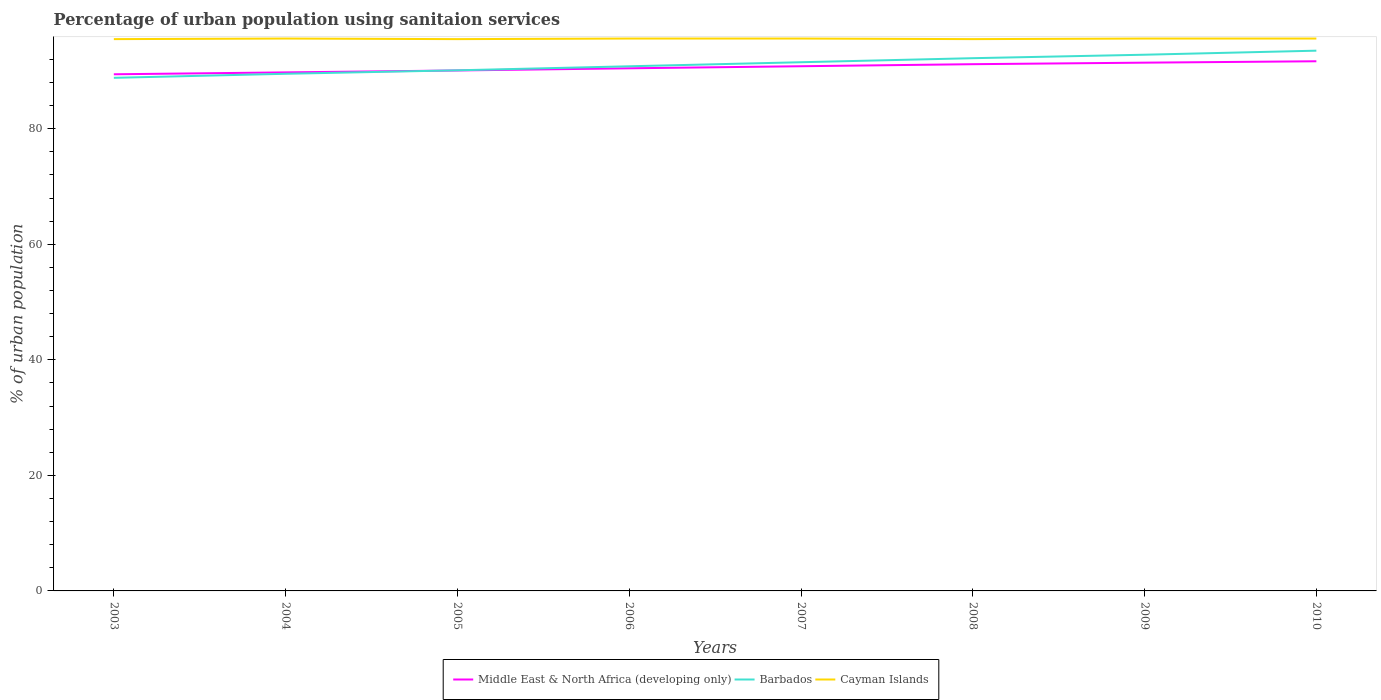Does the line corresponding to Barbados intersect with the line corresponding to Middle East & North Africa (developing only)?
Your answer should be very brief. Yes. Across all years, what is the maximum percentage of urban population using sanitaion services in Cayman Islands?
Offer a terse response. 95.5. In which year was the percentage of urban population using sanitaion services in Cayman Islands maximum?
Keep it short and to the point. 2003. What is the total percentage of urban population using sanitaion services in Middle East & North Africa (developing only) in the graph?
Your response must be concise. -0.33. What is the difference between the highest and the second highest percentage of urban population using sanitaion services in Cayman Islands?
Ensure brevity in your answer.  0.1. What is the difference between the highest and the lowest percentage of urban population using sanitaion services in Middle East & North Africa (developing only)?
Provide a short and direct response. 4. How many years are there in the graph?
Provide a succinct answer. 8. What is the difference between two consecutive major ticks on the Y-axis?
Make the answer very short. 20. Are the values on the major ticks of Y-axis written in scientific E-notation?
Keep it short and to the point. No. How many legend labels are there?
Offer a terse response. 3. How are the legend labels stacked?
Offer a terse response. Horizontal. What is the title of the graph?
Give a very brief answer. Percentage of urban population using sanitaion services. Does "Czech Republic" appear as one of the legend labels in the graph?
Ensure brevity in your answer.  No. What is the label or title of the X-axis?
Your response must be concise. Years. What is the label or title of the Y-axis?
Provide a succinct answer. % of urban population. What is the % of urban population in Middle East & North Africa (developing only) in 2003?
Provide a short and direct response. 89.41. What is the % of urban population in Barbados in 2003?
Your response must be concise. 88.8. What is the % of urban population in Cayman Islands in 2003?
Keep it short and to the point. 95.5. What is the % of urban population in Middle East & North Africa (developing only) in 2004?
Your answer should be very brief. 89.74. What is the % of urban population in Barbados in 2004?
Give a very brief answer. 89.5. What is the % of urban population of Cayman Islands in 2004?
Offer a very short reply. 95.6. What is the % of urban population of Middle East & North Africa (developing only) in 2005?
Your answer should be compact. 90.07. What is the % of urban population in Barbados in 2005?
Provide a short and direct response. 90.1. What is the % of urban population of Cayman Islands in 2005?
Ensure brevity in your answer.  95.5. What is the % of urban population in Middle East & North Africa (developing only) in 2006?
Give a very brief answer. 90.45. What is the % of urban population of Barbados in 2006?
Keep it short and to the point. 90.8. What is the % of urban population of Cayman Islands in 2006?
Provide a short and direct response. 95.6. What is the % of urban population in Middle East & North Africa (developing only) in 2007?
Your response must be concise. 90.81. What is the % of urban population of Barbados in 2007?
Give a very brief answer. 91.5. What is the % of urban population of Cayman Islands in 2007?
Your answer should be compact. 95.6. What is the % of urban population of Middle East & North Africa (developing only) in 2008?
Make the answer very short. 91.16. What is the % of urban population of Barbados in 2008?
Your answer should be very brief. 92.2. What is the % of urban population in Cayman Islands in 2008?
Your answer should be very brief. 95.5. What is the % of urban population in Middle East & North Africa (developing only) in 2009?
Your answer should be very brief. 91.43. What is the % of urban population of Barbados in 2009?
Keep it short and to the point. 92.8. What is the % of urban population of Cayman Islands in 2009?
Your answer should be very brief. 95.6. What is the % of urban population of Middle East & North Africa (developing only) in 2010?
Offer a very short reply. 91.67. What is the % of urban population of Barbados in 2010?
Ensure brevity in your answer.  93.5. What is the % of urban population of Cayman Islands in 2010?
Give a very brief answer. 95.6. Across all years, what is the maximum % of urban population in Middle East & North Africa (developing only)?
Your response must be concise. 91.67. Across all years, what is the maximum % of urban population in Barbados?
Provide a succinct answer. 93.5. Across all years, what is the maximum % of urban population in Cayman Islands?
Ensure brevity in your answer.  95.6. Across all years, what is the minimum % of urban population of Middle East & North Africa (developing only)?
Keep it short and to the point. 89.41. Across all years, what is the minimum % of urban population of Barbados?
Offer a very short reply. 88.8. Across all years, what is the minimum % of urban population in Cayman Islands?
Ensure brevity in your answer.  95.5. What is the total % of urban population in Middle East & North Africa (developing only) in the graph?
Keep it short and to the point. 724.74. What is the total % of urban population of Barbados in the graph?
Ensure brevity in your answer.  729.2. What is the total % of urban population in Cayman Islands in the graph?
Your answer should be compact. 764.5. What is the difference between the % of urban population of Middle East & North Africa (developing only) in 2003 and that in 2004?
Ensure brevity in your answer.  -0.33. What is the difference between the % of urban population of Barbados in 2003 and that in 2004?
Make the answer very short. -0.7. What is the difference between the % of urban population in Cayman Islands in 2003 and that in 2004?
Your answer should be compact. -0.1. What is the difference between the % of urban population in Middle East & North Africa (developing only) in 2003 and that in 2005?
Provide a succinct answer. -0.66. What is the difference between the % of urban population of Cayman Islands in 2003 and that in 2005?
Ensure brevity in your answer.  0. What is the difference between the % of urban population of Middle East & North Africa (developing only) in 2003 and that in 2006?
Provide a succinct answer. -1.04. What is the difference between the % of urban population in Barbados in 2003 and that in 2006?
Offer a terse response. -2. What is the difference between the % of urban population in Middle East & North Africa (developing only) in 2003 and that in 2007?
Offer a terse response. -1.39. What is the difference between the % of urban population in Cayman Islands in 2003 and that in 2007?
Make the answer very short. -0.1. What is the difference between the % of urban population in Middle East & North Africa (developing only) in 2003 and that in 2008?
Provide a short and direct response. -1.75. What is the difference between the % of urban population of Cayman Islands in 2003 and that in 2008?
Your response must be concise. 0. What is the difference between the % of urban population in Middle East & North Africa (developing only) in 2003 and that in 2009?
Offer a terse response. -2.01. What is the difference between the % of urban population of Cayman Islands in 2003 and that in 2009?
Offer a very short reply. -0.1. What is the difference between the % of urban population in Middle East & North Africa (developing only) in 2003 and that in 2010?
Give a very brief answer. -2.25. What is the difference between the % of urban population in Middle East & North Africa (developing only) in 2004 and that in 2005?
Your response must be concise. -0.33. What is the difference between the % of urban population in Barbados in 2004 and that in 2005?
Ensure brevity in your answer.  -0.6. What is the difference between the % of urban population in Cayman Islands in 2004 and that in 2005?
Offer a very short reply. 0.1. What is the difference between the % of urban population in Middle East & North Africa (developing only) in 2004 and that in 2006?
Keep it short and to the point. -0.71. What is the difference between the % of urban population in Barbados in 2004 and that in 2006?
Give a very brief answer. -1.3. What is the difference between the % of urban population in Middle East & North Africa (developing only) in 2004 and that in 2007?
Provide a short and direct response. -1.06. What is the difference between the % of urban population in Barbados in 2004 and that in 2007?
Your answer should be compact. -2. What is the difference between the % of urban population of Cayman Islands in 2004 and that in 2007?
Make the answer very short. 0. What is the difference between the % of urban population of Middle East & North Africa (developing only) in 2004 and that in 2008?
Your response must be concise. -1.42. What is the difference between the % of urban population of Cayman Islands in 2004 and that in 2008?
Ensure brevity in your answer.  0.1. What is the difference between the % of urban population of Middle East & North Africa (developing only) in 2004 and that in 2009?
Give a very brief answer. -1.69. What is the difference between the % of urban population of Barbados in 2004 and that in 2009?
Offer a terse response. -3.3. What is the difference between the % of urban population in Middle East & North Africa (developing only) in 2004 and that in 2010?
Provide a succinct answer. -1.92. What is the difference between the % of urban population in Middle East & North Africa (developing only) in 2005 and that in 2006?
Offer a terse response. -0.38. What is the difference between the % of urban population of Barbados in 2005 and that in 2006?
Your answer should be compact. -0.7. What is the difference between the % of urban population of Middle East & North Africa (developing only) in 2005 and that in 2007?
Provide a succinct answer. -0.73. What is the difference between the % of urban population of Barbados in 2005 and that in 2007?
Offer a very short reply. -1.4. What is the difference between the % of urban population of Cayman Islands in 2005 and that in 2007?
Keep it short and to the point. -0.1. What is the difference between the % of urban population in Middle East & North Africa (developing only) in 2005 and that in 2008?
Offer a very short reply. -1.09. What is the difference between the % of urban population of Barbados in 2005 and that in 2008?
Provide a short and direct response. -2.1. What is the difference between the % of urban population in Middle East & North Africa (developing only) in 2005 and that in 2009?
Your response must be concise. -1.35. What is the difference between the % of urban population in Barbados in 2005 and that in 2009?
Ensure brevity in your answer.  -2.7. What is the difference between the % of urban population of Middle East & North Africa (developing only) in 2005 and that in 2010?
Give a very brief answer. -1.59. What is the difference between the % of urban population in Middle East & North Africa (developing only) in 2006 and that in 2007?
Offer a terse response. -0.36. What is the difference between the % of urban population in Barbados in 2006 and that in 2007?
Your answer should be compact. -0.7. What is the difference between the % of urban population in Middle East & North Africa (developing only) in 2006 and that in 2008?
Give a very brief answer. -0.71. What is the difference between the % of urban population of Cayman Islands in 2006 and that in 2008?
Your response must be concise. 0.1. What is the difference between the % of urban population in Middle East & North Africa (developing only) in 2006 and that in 2009?
Make the answer very short. -0.98. What is the difference between the % of urban population of Cayman Islands in 2006 and that in 2009?
Your answer should be very brief. 0. What is the difference between the % of urban population in Middle East & North Africa (developing only) in 2006 and that in 2010?
Make the answer very short. -1.22. What is the difference between the % of urban population of Middle East & North Africa (developing only) in 2007 and that in 2008?
Your response must be concise. -0.36. What is the difference between the % of urban population in Cayman Islands in 2007 and that in 2008?
Provide a short and direct response. 0.1. What is the difference between the % of urban population of Middle East & North Africa (developing only) in 2007 and that in 2009?
Provide a short and direct response. -0.62. What is the difference between the % of urban population in Barbados in 2007 and that in 2009?
Your response must be concise. -1.3. What is the difference between the % of urban population of Cayman Islands in 2007 and that in 2009?
Ensure brevity in your answer.  0. What is the difference between the % of urban population in Middle East & North Africa (developing only) in 2007 and that in 2010?
Keep it short and to the point. -0.86. What is the difference between the % of urban population in Barbados in 2007 and that in 2010?
Offer a very short reply. -2. What is the difference between the % of urban population in Cayman Islands in 2007 and that in 2010?
Ensure brevity in your answer.  0. What is the difference between the % of urban population of Middle East & North Africa (developing only) in 2008 and that in 2009?
Your answer should be compact. -0.27. What is the difference between the % of urban population in Cayman Islands in 2008 and that in 2009?
Provide a short and direct response. -0.1. What is the difference between the % of urban population in Middle East & North Africa (developing only) in 2008 and that in 2010?
Your answer should be very brief. -0.5. What is the difference between the % of urban population in Cayman Islands in 2008 and that in 2010?
Provide a succinct answer. -0.1. What is the difference between the % of urban population in Middle East & North Africa (developing only) in 2009 and that in 2010?
Offer a very short reply. -0.24. What is the difference between the % of urban population of Barbados in 2009 and that in 2010?
Your response must be concise. -0.7. What is the difference between the % of urban population of Cayman Islands in 2009 and that in 2010?
Offer a very short reply. 0. What is the difference between the % of urban population of Middle East & North Africa (developing only) in 2003 and the % of urban population of Barbados in 2004?
Provide a short and direct response. -0.09. What is the difference between the % of urban population of Middle East & North Africa (developing only) in 2003 and the % of urban population of Cayman Islands in 2004?
Make the answer very short. -6.19. What is the difference between the % of urban population of Barbados in 2003 and the % of urban population of Cayman Islands in 2004?
Your response must be concise. -6.8. What is the difference between the % of urban population in Middle East & North Africa (developing only) in 2003 and the % of urban population in Barbados in 2005?
Make the answer very short. -0.69. What is the difference between the % of urban population of Middle East & North Africa (developing only) in 2003 and the % of urban population of Cayman Islands in 2005?
Offer a very short reply. -6.09. What is the difference between the % of urban population in Middle East & North Africa (developing only) in 2003 and the % of urban population in Barbados in 2006?
Provide a short and direct response. -1.39. What is the difference between the % of urban population of Middle East & North Africa (developing only) in 2003 and the % of urban population of Cayman Islands in 2006?
Offer a terse response. -6.19. What is the difference between the % of urban population in Middle East & North Africa (developing only) in 2003 and the % of urban population in Barbados in 2007?
Give a very brief answer. -2.09. What is the difference between the % of urban population of Middle East & North Africa (developing only) in 2003 and the % of urban population of Cayman Islands in 2007?
Give a very brief answer. -6.19. What is the difference between the % of urban population in Barbados in 2003 and the % of urban population in Cayman Islands in 2007?
Keep it short and to the point. -6.8. What is the difference between the % of urban population of Middle East & North Africa (developing only) in 2003 and the % of urban population of Barbados in 2008?
Ensure brevity in your answer.  -2.79. What is the difference between the % of urban population in Middle East & North Africa (developing only) in 2003 and the % of urban population in Cayman Islands in 2008?
Offer a very short reply. -6.09. What is the difference between the % of urban population in Middle East & North Africa (developing only) in 2003 and the % of urban population in Barbados in 2009?
Your answer should be compact. -3.39. What is the difference between the % of urban population of Middle East & North Africa (developing only) in 2003 and the % of urban population of Cayman Islands in 2009?
Your answer should be very brief. -6.19. What is the difference between the % of urban population of Middle East & North Africa (developing only) in 2003 and the % of urban population of Barbados in 2010?
Offer a very short reply. -4.09. What is the difference between the % of urban population in Middle East & North Africa (developing only) in 2003 and the % of urban population in Cayman Islands in 2010?
Offer a very short reply. -6.19. What is the difference between the % of urban population of Middle East & North Africa (developing only) in 2004 and the % of urban population of Barbados in 2005?
Provide a short and direct response. -0.36. What is the difference between the % of urban population in Middle East & North Africa (developing only) in 2004 and the % of urban population in Cayman Islands in 2005?
Keep it short and to the point. -5.76. What is the difference between the % of urban population of Barbados in 2004 and the % of urban population of Cayman Islands in 2005?
Keep it short and to the point. -6. What is the difference between the % of urban population in Middle East & North Africa (developing only) in 2004 and the % of urban population in Barbados in 2006?
Offer a very short reply. -1.06. What is the difference between the % of urban population in Middle East & North Africa (developing only) in 2004 and the % of urban population in Cayman Islands in 2006?
Offer a very short reply. -5.86. What is the difference between the % of urban population in Barbados in 2004 and the % of urban population in Cayman Islands in 2006?
Your response must be concise. -6.1. What is the difference between the % of urban population in Middle East & North Africa (developing only) in 2004 and the % of urban population in Barbados in 2007?
Provide a short and direct response. -1.76. What is the difference between the % of urban population of Middle East & North Africa (developing only) in 2004 and the % of urban population of Cayman Islands in 2007?
Your answer should be compact. -5.86. What is the difference between the % of urban population of Middle East & North Africa (developing only) in 2004 and the % of urban population of Barbados in 2008?
Make the answer very short. -2.46. What is the difference between the % of urban population in Middle East & North Africa (developing only) in 2004 and the % of urban population in Cayman Islands in 2008?
Keep it short and to the point. -5.76. What is the difference between the % of urban population in Barbados in 2004 and the % of urban population in Cayman Islands in 2008?
Your answer should be very brief. -6. What is the difference between the % of urban population in Middle East & North Africa (developing only) in 2004 and the % of urban population in Barbados in 2009?
Your response must be concise. -3.06. What is the difference between the % of urban population of Middle East & North Africa (developing only) in 2004 and the % of urban population of Cayman Islands in 2009?
Provide a succinct answer. -5.86. What is the difference between the % of urban population in Middle East & North Africa (developing only) in 2004 and the % of urban population in Barbados in 2010?
Offer a very short reply. -3.76. What is the difference between the % of urban population of Middle East & North Africa (developing only) in 2004 and the % of urban population of Cayman Islands in 2010?
Offer a terse response. -5.86. What is the difference between the % of urban population in Barbados in 2004 and the % of urban population in Cayman Islands in 2010?
Your answer should be compact. -6.1. What is the difference between the % of urban population in Middle East & North Africa (developing only) in 2005 and the % of urban population in Barbados in 2006?
Keep it short and to the point. -0.73. What is the difference between the % of urban population in Middle East & North Africa (developing only) in 2005 and the % of urban population in Cayman Islands in 2006?
Make the answer very short. -5.53. What is the difference between the % of urban population of Middle East & North Africa (developing only) in 2005 and the % of urban population of Barbados in 2007?
Offer a very short reply. -1.43. What is the difference between the % of urban population in Middle East & North Africa (developing only) in 2005 and the % of urban population in Cayman Islands in 2007?
Provide a short and direct response. -5.53. What is the difference between the % of urban population of Barbados in 2005 and the % of urban population of Cayman Islands in 2007?
Offer a terse response. -5.5. What is the difference between the % of urban population in Middle East & North Africa (developing only) in 2005 and the % of urban population in Barbados in 2008?
Your answer should be very brief. -2.13. What is the difference between the % of urban population of Middle East & North Africa (developing only) in 2005 and the % of urban population of Cayman Islands in 2008?
Provide a short and direct response. -5.43. What is the difference between the % of urban population in Barbados in 2005 and the % of urban population in Cayman Islands in 2008?
Keep it short and to the point. -5.4. What is the difference between the % of urban population of Middle East & North Africa (developing only) in 2005 and the % of urban population of Barbados in 2009?
Make the answer very short. -2.73. What is the difference between the % of urban population of Middle East & North Africa (developing only) in 2005 and the % of urban population of Cayman Islands in 2009?
Provide a succinct answer. -5.53. What is the difference between the % of urban population in Middle East & North Africa (developing only) in 2005 and the % of urban population in Barbados in 2010?
Keep it short and to the point. -3.43. What is the difference between the % of urban population in Middle East & North Africa (developing only) in 2005 and the % of urban population in Cayman Islands in 2010?
Offer a terse response. -5.53. What is the difference between the % of urban population of Barbados in 2005 and the % of urban population of Cayman Islands in 2010?
Your answer should be very brief. -5.5. What is the difference between the % of urban population in Middle East & North Africa (developing only) in 2006 and the % of urban population in Barbados in 2007?
Keep it short and to the point. -1.05. What is the difference between the % of urban population of Middle East & North Africa (developing only) in 2006 and the % of urban population of Cayman Islands in 2007?
Your answer should be very brief. -5.15. What is the difference between the % of urban population in Middle East & North Africa (developing only) in 2006 and the % of urban population in Barbados in 2008?
Provide a succinct answer. -1.75. What is the difference between the % of urban population in Middle East & North Africa (developing only) in 2006 and the % of urban population in Cayman Islands in 2008?
Your response must be concise. -5.05. What is the difference between the % of urban population of Barbados in 2006 and the % of urban population of Cayman Islands in 2008?
Your answer should be very brief. -4.7. What is the difference between the % of urban population in Middle East & North Africa (developing only) in 2006 and the % of urban population in Barbados in 2009?
Make the answer very short. -2.35. What is the difference between the % of urban population of Middle East & North Africa (developing only) in 2006 and the % of urban population of Cayman Islands in 2009?
Your answer should be compact. -5.15. What is the difference between the % of urban population in Middle East & North Africa (developing only) in 2006 and the % of urban population in Barbados in 2010?
Make the answer very short. -3.05. What is the difference between the % of urban population of Middle East & North Africa (developing only) in 2006 and the % of urban population of Cayman Islands in 2010?
Provide a short and direct response. -5.15. What is the difference between the % of urban population of Middle East & North Africa (developing only) in 2007 and the % of urban population of Barbados in 2008?
Keep it short and to the point. -1.39. What is the difference between the % of urban population in Middle East & North Africa (developing only) in 2007 and the % of urban population in Cayman Islands in 2008?
Offer a terse response. -4.69. What is the difference between the % of urban population of Barbados in 2007 and the % of urban population of Cayman Islands in 2008?
Provide a short and direct response. -4. What is the difference between the % of urban population of Middle East & North Africa (developing only) in 2007 and the % of urban population of Barbados in 2009?
Ensure brevity in your answer.  -1.99. What is the difference between the % of urban population in Middle East & North Africa (developing only) in 2007 and the % of urban population in Cayman Islands in 2009?
Give a very brief answer. -4.79. What is the difference between the % of urban population in Barbados in 2007 and the % of urban population in Cayman Islands in 2009?
Your answer should be very brief. -4.1. What is the difference between the % of urban population of Middle East & North Africa (developing only) in 2007 and the % of urban population of Barbados in 2010?
Your answer should be compact. -2.69. What is the difference between the % of urban population in Middle East & North Africa (developing only) in 2007 and the % of urban population in Cayman Islands in 2010?
Provide a short and direct response. -4.79. What is the difference between the % of urban population of Middle East & North Africa (developing only) in 2008 and the % of urban population of Barbados in 2009?
Your response must be concise. -1.64. What is the difference between the % of urban population of Middle East & North Africa (developing only) in 2008 and the % of urban population of Cayman Islands in 2009?
Your answer should be very brief. -4.44. What is the difference between the % of urban population in Barbados in 2008 and the % of urban population in Cayman Islands in 2009?
Offer a terse response. -3.4. What is the difference between the % of urban population in Middle East & North Africa (developing only) in 2008 and the % of urban population in Barbados in 2010?
Offer a terse response. -2.34. What is the difference between the % of urban population of Middle East & North Africa (developing only) in 2008 and the % of urban population of Cayman Islands in 2010?
Provide a short and direct response. -4.44. What is the difference between the % of urban population of Barbados in 2008 and the % of urban population of Cayman Islands in 2010?
Provide a succinct answer. -3.4. What is the difference between the % of urban population in Middle East & North Africa (developing only) in 2009 and the % of urban population in Barbados in 2010?
Your answer should be very brief. -2.07. What is the difference between the % of urban population in Middle East & North Africa (developing only) in 2009 and the % of urban population in Cayman Islands in 2010?
Give a very brief answer. -4.17. What is the average % of urban population in Middle East & North Africa (developing only) per year?
Provide a short and direct response. 90.59. What is the average % of urban population of Barbados per year?
Give a very brief answer. 91.15. What is the average % of urban population in Cayman Islands per year?
Provide a short and direct response. 95.56. In the year 2003, what is the difference between the % of urban population of Middle East & North Africa (developing only) and % of urban population of Barbados?
Your response must be concise. 0.61. In the year 2003, what is the difference between the % of urban population in Middle East & North Africa (developing only) and % of urban population in Cayman Islands?
Ensure brevity in your answer.  -6.09. In the year 2004, what is the difference between the % of urban population in Middle East & North Africa (developing only) and % of urban population in Barbados?
Keep it short and to the point. 0.24. In the year 2004, what is the difference between the % of urban population in Middle East & North Africa (developing only) and % of urban population in Cayman Islands?
Provide a short and direct response. -5.86. In the year 2004, what is the difference between the % of urban population of Barbados and % of urban population of Cayman Islands?
Give a very brief answer. -6.1. In the year 2005, what is the difference between the % of urban population of Middle East & North Africa (developing only) and % of urban population of Barbados?
Give a very brief answer. -0.03. In the year 2005, what is the difference between the % of urban population in Middle East & North Africa (developing only) and % of urban population in Cayman Islands?
Your response must be concise. -5.43. In the year 2006, what is the difference between the % of urban population in Middle East & North Africa (developing only) and % of urban population in Barbados?
Offer a very short reply. -0.35. In the year 2006, what is the difference between the % of urban population of Middle East & North Africa (developing only) and % of urban population of Cayman Islands?
Provide a succinct answer. -5.15. In the year 2006, what is the difference between the % of urban population in Barbados and % of urban population in Cayman Islands?
Your response must be concise. -4.8. In the year 2007, what is the difference between the % of urban population in Middle East & North Africa (developing only) and % of urban population in Barbados?
Your answer should be very brief. -0.69. In the year 2007, what is the difference between the % of urban population in Middle East & North Africa (developing only) and % of urban population in Cayman Islands?
Your answer should be very brief. -4.79. In the year 2008, what is the difference between the % of urban population in Middle East & North Africa (developing only) and % of urban population in Barbados?
Provide a succinct answer. -1.04. In the year 2008, what is the difference between the % of urban population in Middle East & North Africa (developing only) and % of urban population in Cayman Islands?
Offer a terse response. -4.34. In the year 2009, what is the difference between the % of urban population of Middle East & North Africa (developing only) and % of urban population of Barbados?
Your answer should be very brief. -1.37. In the year 2009, what is the difference between the % of urban population in Middle East & North Africa (developing only) and % of urban population in Cayman Islands?
Ensure brevity in your answer.  -4.17. In the year 2010, what is the difference between the % of urban population of Middle East & North Africa (developing only) and % of urban population of Barbados?
Provide a succinct answer. -1.83. In the year 2010, what is the difference between the % of urban population in Middle East & North Africa (developing only) and % of urban population in Cayman Islands?
Your answer should be very brief. -3.93. What is the ratio of the % of urban population of Cayman Islands in 2003 to that in 2004?
Keep it short and to the point. 1. What is the ratio of the % of urban population of Barbados in 2003 to that in 2005?
Provide a succinct answer. 0.99. What is the ratio of the % of urban population of Barbados in 2003 to that in 2006?
Your answer should be very brief. 0.98. What is the ratio of the % of urban population of Middle East & North Africa (developing only) in 2003 to that in 2007?
Your response must be concise. 0.98. What is the ratio of the % of urban population in Barbados in 2003 to that in 2007?
Offer a very short reply. 0.97. What is the ratio of the % of urban population in Middle East & North Africa (developing only) in 2003 to that in 2008?
Give a very brief answer. 0.98. What is the ratio of the % of urban population of Barbados in 2003 to that in 2008?
Offer a very short reply. 0.96. What is the ratio of the % of urban population in Middle East & North Africa (developing only) in 2003 to that in 2009?
Your answer should be very brief. 0.98. What is the ratio of the % of urban population of Barbados in 2003 to that in 2009?
Make the answer very short. 0.96. What is the ratio of the % of urban population in Cayman Islands in 2003 to that in 2009?
Your response must be concise. 1. What is the ratio of the % of urban population in Middle East & North Africa (developing only) in 2003 to that in 2010?
Provide a succinct answer. 0.98. What is the ratio of the % of urban population of Barbados in 2003 to that in 2010?
Offer a very short reply. 0.95. What is the ratio of the % of urban population of Cayman Islands in 2003 to that in 2010?
Offer a very short reply. 1. What is the ratio of the % of urban population of Middle East & North Africa (developing only) in 2004 to that in 2005?
Your answer should be very brief. 1. What is the ratio of the % of urban population of Barbados in 2004 to that in 2005?
Your answer should be very brief. 0.99. What is the ratio of the % of urban population in Cayman Islands in 2004 to that in 2005?
Your response must be concise. 1. What is the ratio of the % of urban population of Barbados in 2004 to that in 2006?
Provide a succinct answer. 0.99. What is the ratio of the % of urban population of Cayman Islands in 2004 to that in 2006?
Your answer should be compact. 1. What is the ratio of the % of urban population in Middle East & North Africa (developing only) in 2004 to that in 2007?
Your answer should be very brief. 0.99. What is the ratio of the % of urban population in Barbados in 2004 to that in 2007?
Provide a succinct answer. 0.98. What is the ratio of the % of urban population of Cayman Islands in 2004 to that in 2007?
Provide a succinct answer. 1. What is the ratio of the % of urban population in Middle East & North Africa (developing only) in 2004 to that in 2008?
Your response must be concise. 0.98. What is the ratio of the % of urban population in Barbados in 2004 to that in 2008?
Provide a succinct answer. 0.97. What is the ratio of the % of urban population of Cayman Islands in 2004 to that in 2008?
Provide a succinct answer. 1. What is the ratio of the % of urban population in Middle East & North Africa (developing only) in 2004 to that in 2009?
Give a very brief answer. 0.98. What is the ratio of the % of urban population in Barbados in 2004 to that in 2009?
Make the answer very short. 0.96. What is the ratio of the % of urban population in Barbados in 2004 to that in 2010?
Ensure brevity in your answer.  0.96. What is the ratio of the % of urban population in Middle East & North Africa (developing only) in 2005 to that in 2006?
Offer a very short reply. 1. What is the ratio of the % of urban population in Barbados in 2005 to that in 2006?
Provide a succinct answer. 0.99. What is the ratio of the % of urban population of Cayman Islands in 2005 to that in 2006?
Your answer should be very brief. 1. What is the ratio of the % of urban population of Middle East & North Africa (developing only) in 2005 to that in 2007?
Provide a short and direct response. 0.99. What is the ratio of the % of urban population of Barbados in 2005 to that in 2007?
Provide a short and direct response. 0.98. What is the ratio of the % of urban population of Middle East & North Africa (developing only) in 2005 to that in 2008?
Your answer should be very brief. 0.99. What is the ratio of the % of urban population in Barbados in 2005 to that in 2008?
Provide a succinct answer. 0.98. What is the ratio of the % of urban population in Cayman Islands in 2005 to that in 2008?
Your answer should be compact. 1. What is the ratio of the % of urban population in Middle East & North Africa (developing only) in 2005 to that in 2009?
Make the answer very short. 0.99. What is the ratio of the % of urban population in Barbados in 2005 to that in 2009?
Ensure brevity in your answer.  0.97. What is the ratio of the % of urban population in Cayman Islands in 2005 to that in 2009?
Give a very brief answer. 1. What is the ratio of the % of urban population in Middle East & North Africa (developing only) in 2005 to that in 2010?
Provide a succinct answer. 0.98. What is the ratio of the % of urban population in Barbados in 2005 to that in 2010?
Your response must be concise. 0.96. What is the ratio of the % of urban population in Cayman Islands in 2005 to that in 2010?
Your answer should be compact. 1. What is the ratio of the % of urban population of Middle East & North Africa (developing only) in 2006 to that in 2007?
Provide a succinct answer. 1. What is the ratio of the % of urban population of Barbados in 2006 to that in 2007?
Give a very brief answer. 0.99. What is the ratio of the % of urban population of Middle East & North Africa (developing only) in 2006 to that in 2008?
Keep it short and to the point. 0.99. What is the ratio of the % of urban population in Barbados in 2006 to that in 2008?
Make the answer very short. 0.98. What is the ratio of the % of urban population of Middle East & North Africa (developing only) in 2006 to that in 2009?
Keep it short and to the point. 0.99. What is the ratio of the % of urban population of Barbados in 2006 to that in 2009?
Give a very brief answer. 0.98. What is the ratio of the % of urban population in Cayman Islands in 2006 to that in 2009?
Give a very brief answer. 1. What is the ratio of the % of urban population of Middle East & North Africa (developing only) in 2006 to that in 2010?
Your response must be concise. 0.99. What is the ratio of the % of urban population of Barbados in 2006 to that in 2010?
Offer a terse response. 0.97. What is the ratio of the % of urban population of Middle East & North Africa (developing only) in 2007 to that in 2008?
Provide a short and direct response. 1. What is the ratio of the % of urban population of Barbados in 2007 to that in 2009?
Your answer should be very brief. 0.99. What is the ratio of the % of urban population of Cayman Islands in 2007 to that in 2009?
Offer a terse response. 1. What is the ratio of the % of urban population in Middle East & North Africa (developing only) in 2007 to that in 2010?
Your answer should be compact. 0.99. What is the ratio of the % of urban population in Barbados in 2007 to that in 2010?
Keep it short and to the point. 0.98. What is the ratio of the % of urban population in Cayman Islands in 2007 to that in 2010?
Your response must be concise. 1. What is the ratio of the % of urban population of Barbados in 2008 to that in 2009?
Give a very brief answer. 0.99. What is the ratio of the % of urban population in Barbados in 2008 to that in 2010?
Ensure brevity in your answer.  0.99. What is the ratio of the % of urban population in Cayman Islands in 2008 to that in 2010?
Make the answer very short. 1. What is the difference between the highest and the second highest % of urban population of Middle East & North Africa (developing only)?
Offer a very short reply. 0.24. What is the difference between the highest and the second highest % of urban population of Cayman Islands?
Offer a terse response. 0. What is the difference between the highest and the lowest % of urban population of Middle East & North Africa (developing only)?
Your answer should be compact. 2.25. What is the difference between the highest and the lowest % of urban population of Barbados?
Ensure brevity in your answer.  4.7. 